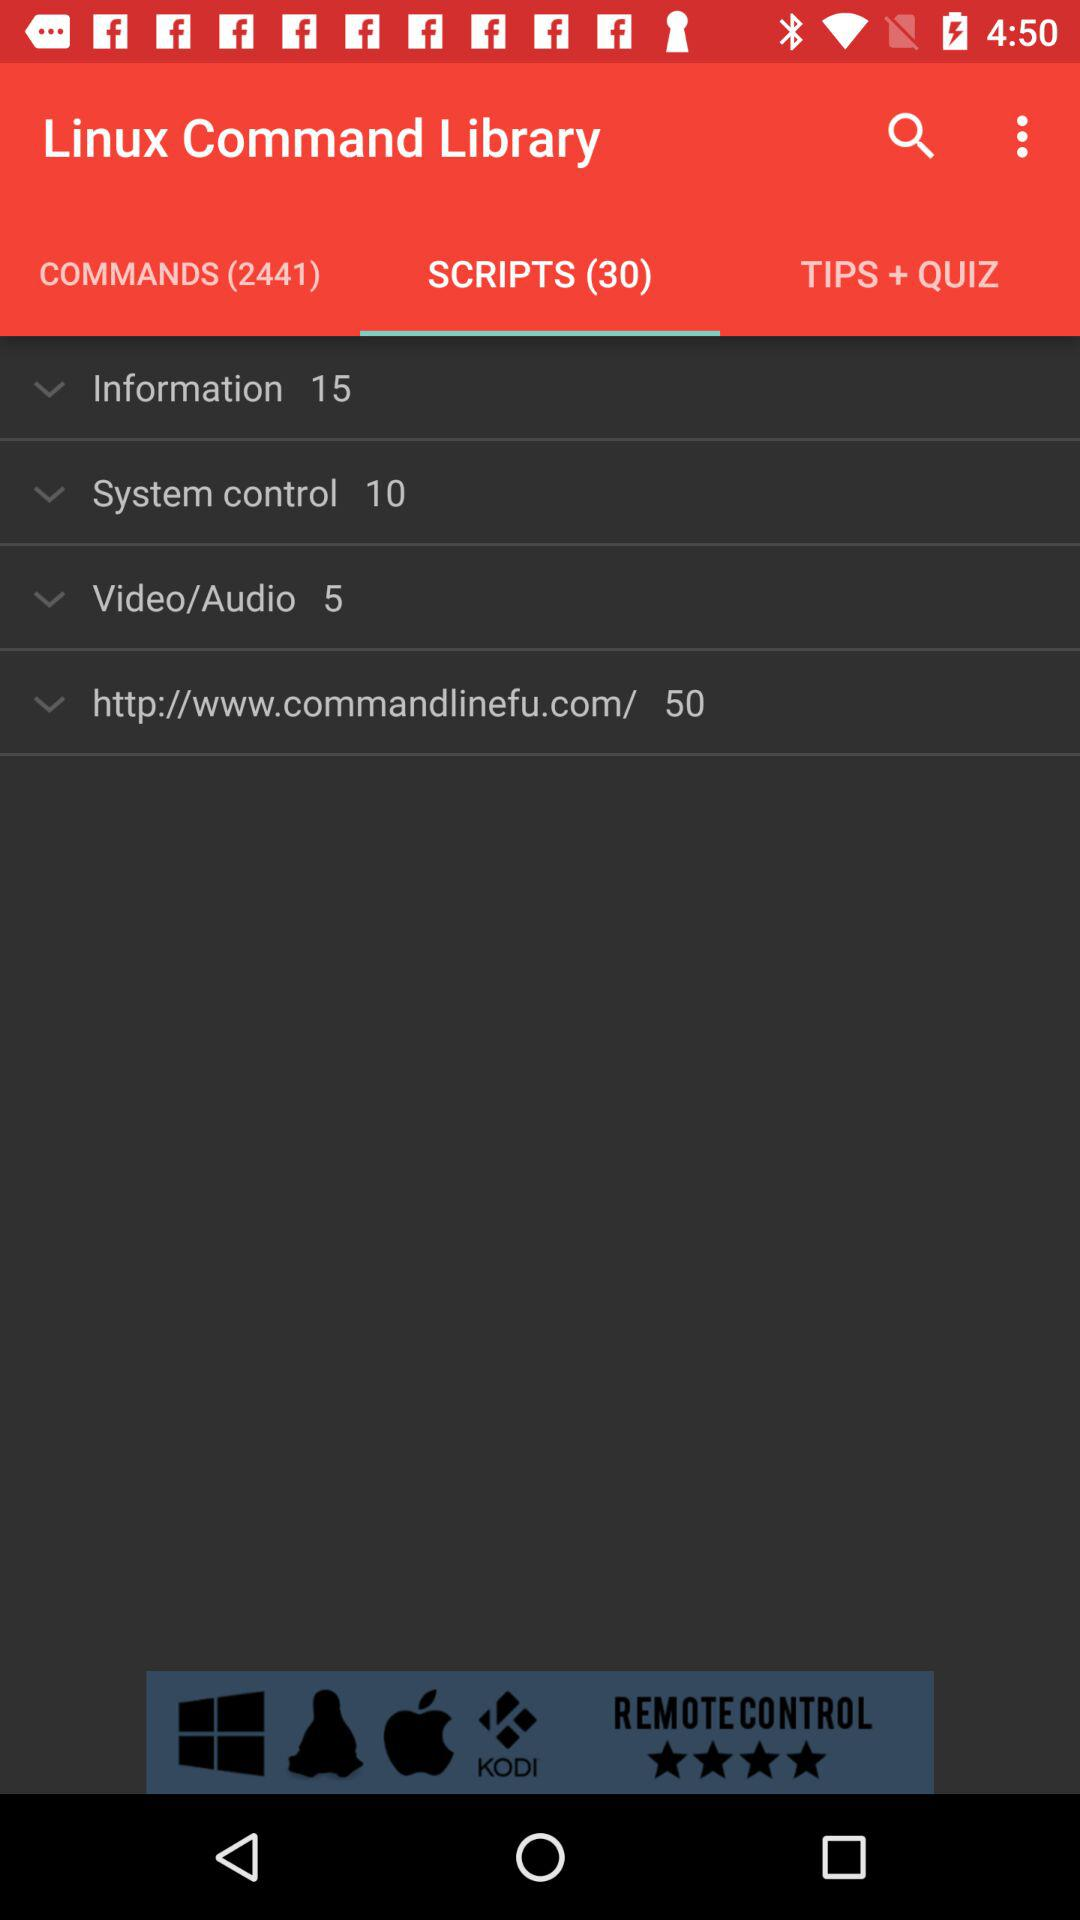How many scripts are there in "Linux Command Library"? There are 30 scripts. 